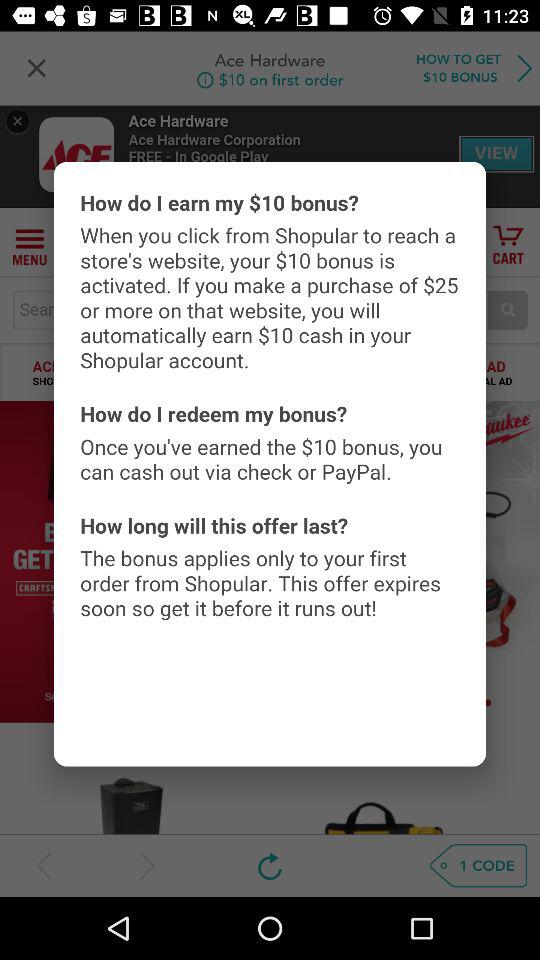How can the bonus amount be redeemed? Once you've earned the $10 bonus, you can cash out via check or PayPal. 